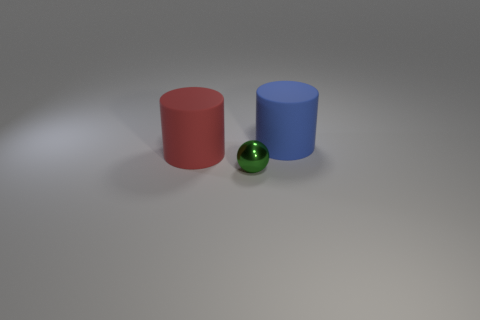Is there any other thing that has the same material as the tiny green sphere?
Your answer should be very brief. No. How many red objects are the same shape as the tiny green shiny object?
Your response must be concise. 0. What is the size of the red object to the left of the thing in front of the large thing that is left of the blue rubber object?
Keep it short and to the point. Large. How many red objects are either matte things or metallic cubes?
Make the answer very short. 1. There is a thing behind the red thing; is it the same shape as the tiny green thing?
Ensure brevity in your answer.  No. Is the number of green shiny objects in front of the big red matte cylinder greater than the number of big cyan metallic blocks?
Provide a succinct answer. Yes. How many red cylinders have the same size as the blue matte thing?
Provide a succinct answer. 1. How many objects are either big cyan rubber blocks or large cylinders that are on the left side of the sphere?
Offer a very short reply. 1. What color is the object that is behind the green ball and in front of the large blue rubber cylinder?
Offer a terse response. Red. Do the red object and the blue thing have the same size?
Ensure brevity in your answer.  Yes. 